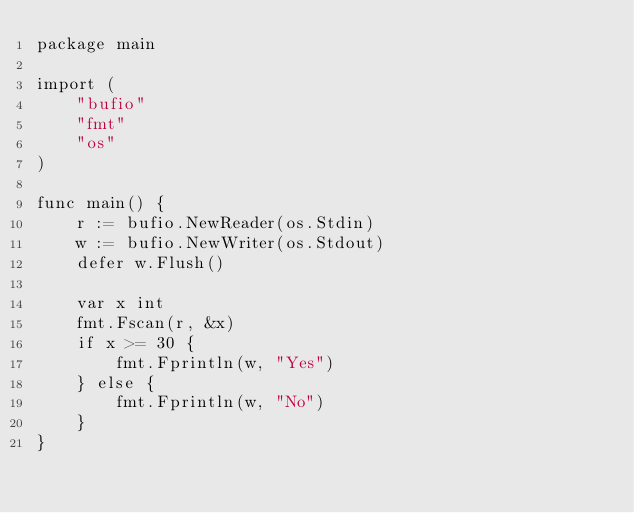<code> <loc_0><loc_0><loc_500><loc_500><_Go_>package main

import (
	"bufio"
	"fmt"
	"os"
)

func main() {
	r := bufio.NewReader(os.Stdin)
	w := bufio.NewWriter(os.Stdout)
	defer w.Flush()

	var x int
	fmt.Fscan(r, &x)
	if x >= 30 {
		fmt.Fprintln(w, "Yes")
	} else {
		fmt.Fprintln(w, "No")
	}
}
</code> 